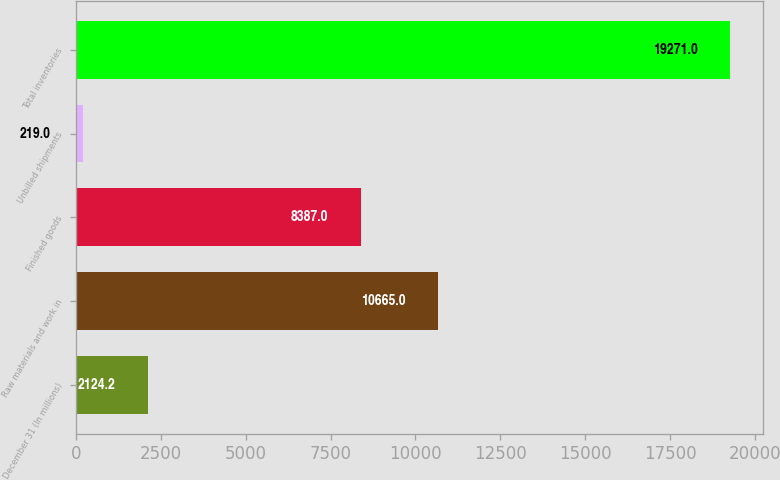Convert chart. <chart><loc_0><loc_0><loc_500><loc_500><bar_chart><fcel>December 31 (In millions)<fcel>Raw materials and work in<fcel>Finished goods<fcel>Unbilled shipments<fcel>Total inventories<nl><fcel>2124.2<fcel>10665<fcel>8387<fcel>219<fcel>19271<nl></chart> 